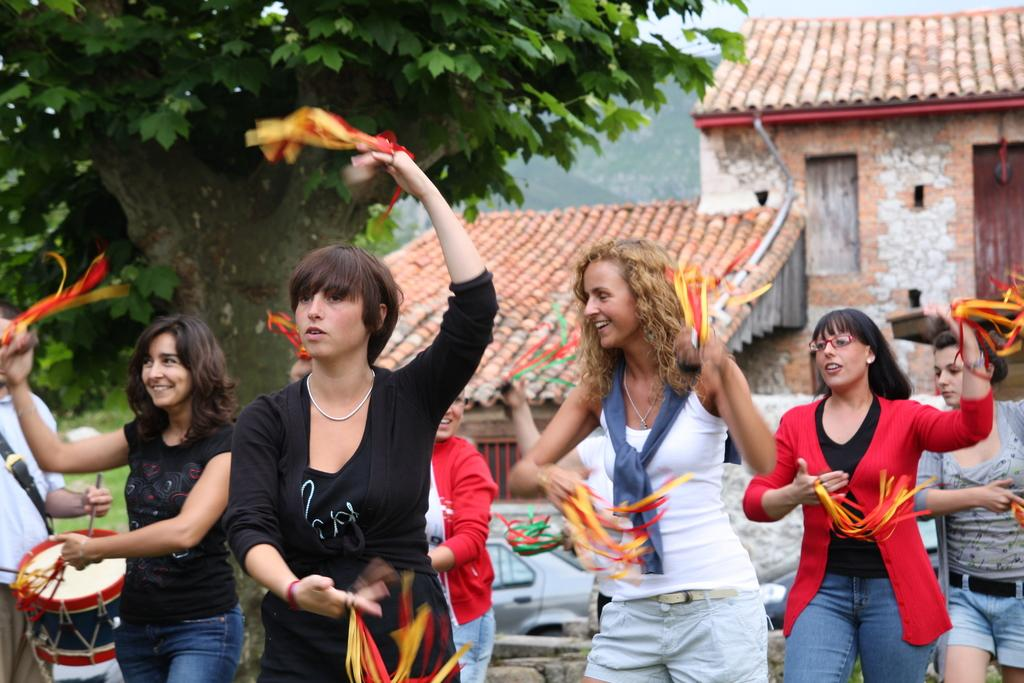What are the people in the image holding? The people in the image are holding pom poms. Can you describe the person on the left side of the image? There is a person wearing a drum on the left side of the image. What can be seen in the background of the image? There is a shed, trees, and the sky visible in the background of the image. What type of nut is visible on the person's face in the image? There is no nut visible on anyone's face in the image. How many ears can be seen on the people in the image? The number of ears cannot be determined from the image, as faces are not clearly visible. 